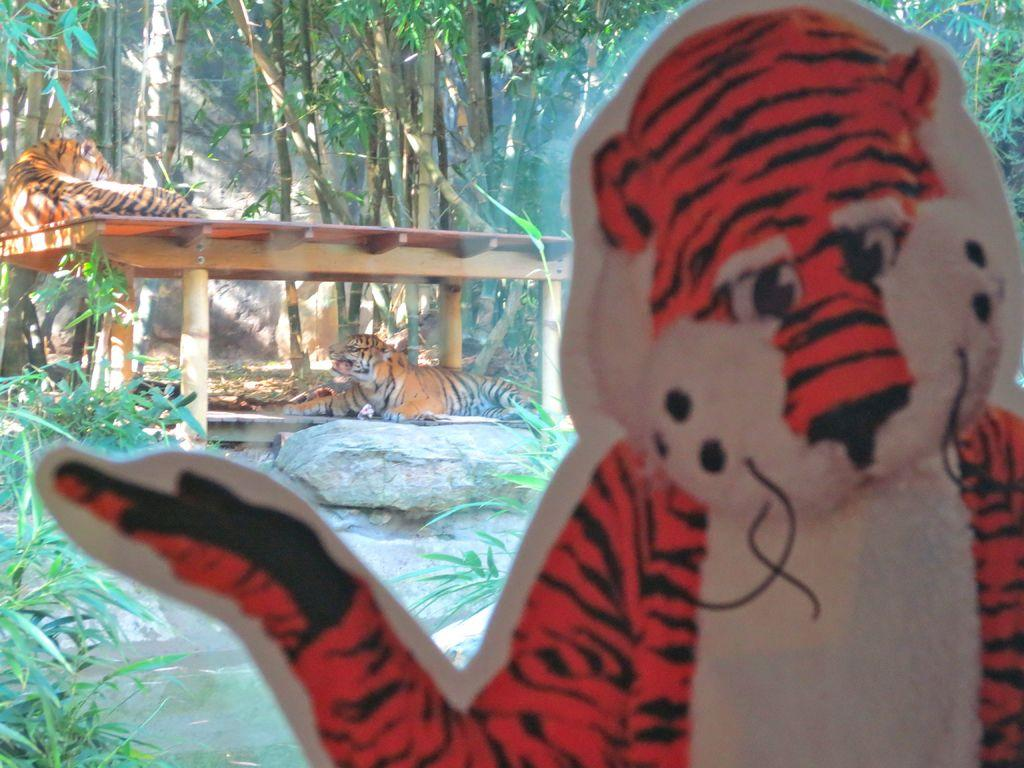What animal is depicted in the image? There is a depiction of a tiger in the image. How many tigers can be seen in the image? There are 2 tigers in the background of the image. What type of terrain is visible in the image? There are stones visible in the image. What type of vegetation is present in the background of the image? Plants and trees are visible in the background of the image. What type of structure is visible in the background of the image? There is a wall in the background of the image. What grade did the tiger receive for its performance in the image? There is no indication of a performance or grade in the image; it simply depicts a tiger and its surroundings. 